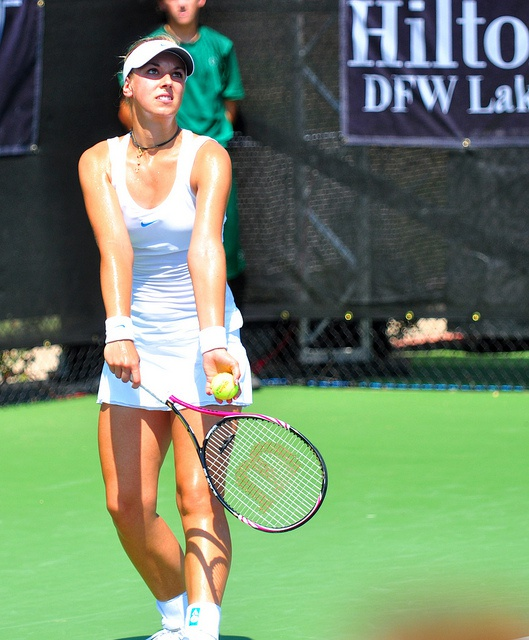Describe the objects in this image and their specific colors. I can see people in gray, white, tan, and brown tones, tennis racket in gray, ivory, and lightgreen tones, people in gray, black, turquoise, and teal tones, and sports ball in gray, beige, yellow, khaki, and lime tones in this image. 